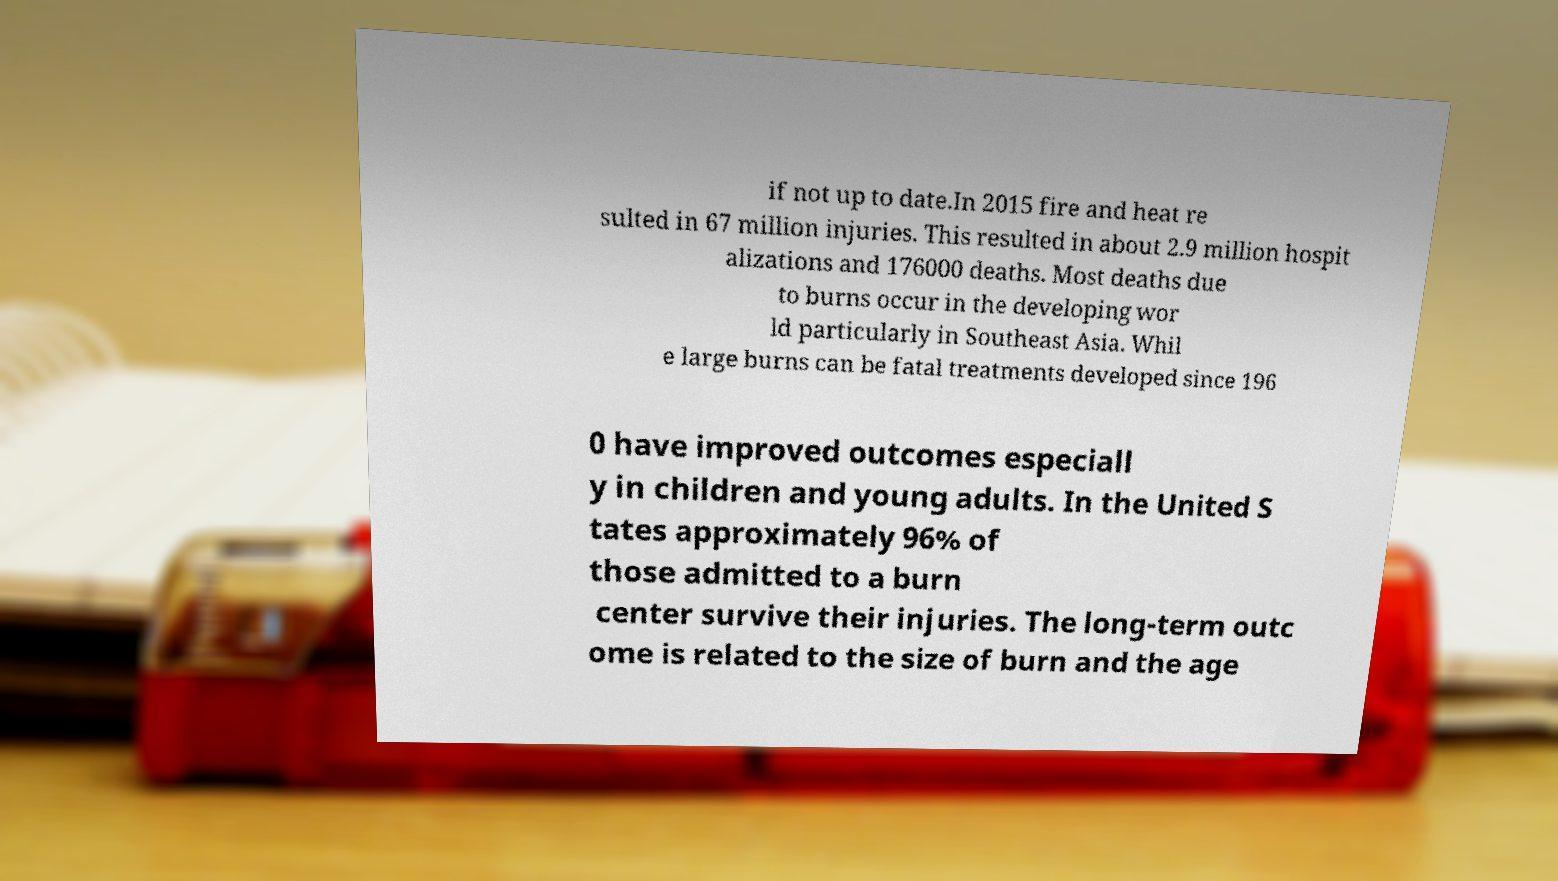Can you accurately transcribe the text from the provided image for me? if not up to date.In 2015 fire and heat re sulted in 67 million injuries. This resulted in about 2.9 million hospit alizations and 176000 deaths. Most deaths due to burns occur in the developing wor ld particularly in Southeast Asia. Whil e large burns can be fatal treatments developed since 196 0 have improved outcomes especiall y in children and young adults. In the United S tates approximately 96% of those admitted to a burn center survive their injuries. The long-term outc ome is related to the size of burn and the age 